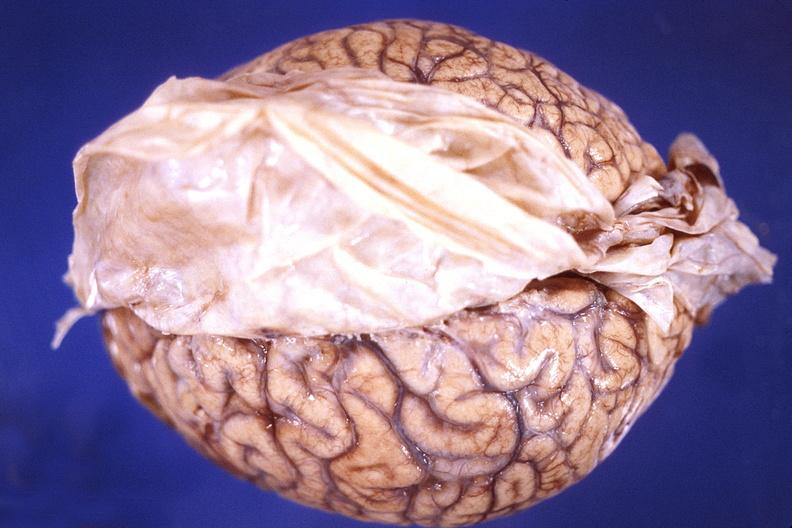s nervous present?
Answer the question using a single word or phrase. Yes 